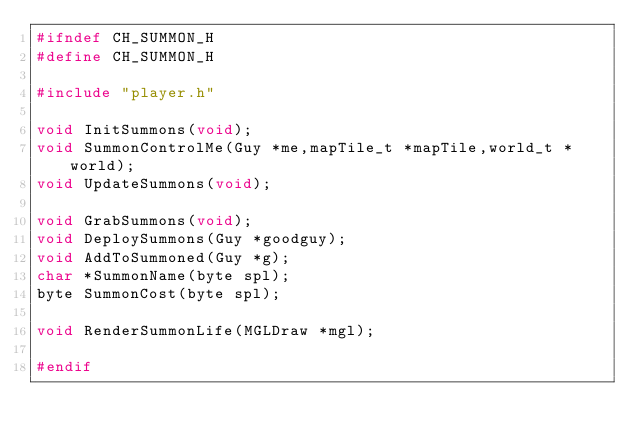<code> <loc_0><loc_0><loc_500><loc_500><_C_>#ifndef CH_SUMMON_H
#define CH_SUMMON_H

#include "player.h"

void InitSummons(void);
void SummonControlMe(Guy *me,mapTile_t *mapTile,world_t *world);
void UpdateSummons(void);

void GrabSummons(void);
void DeploySummons(Guy *goodguy);
void AddToSummoned(Guy *g);
char *SummonName(byte spl);
byte SummonCost(byte spl);

void RenderSummonLife(MGLDraw *mgl);

#endif
</code> 